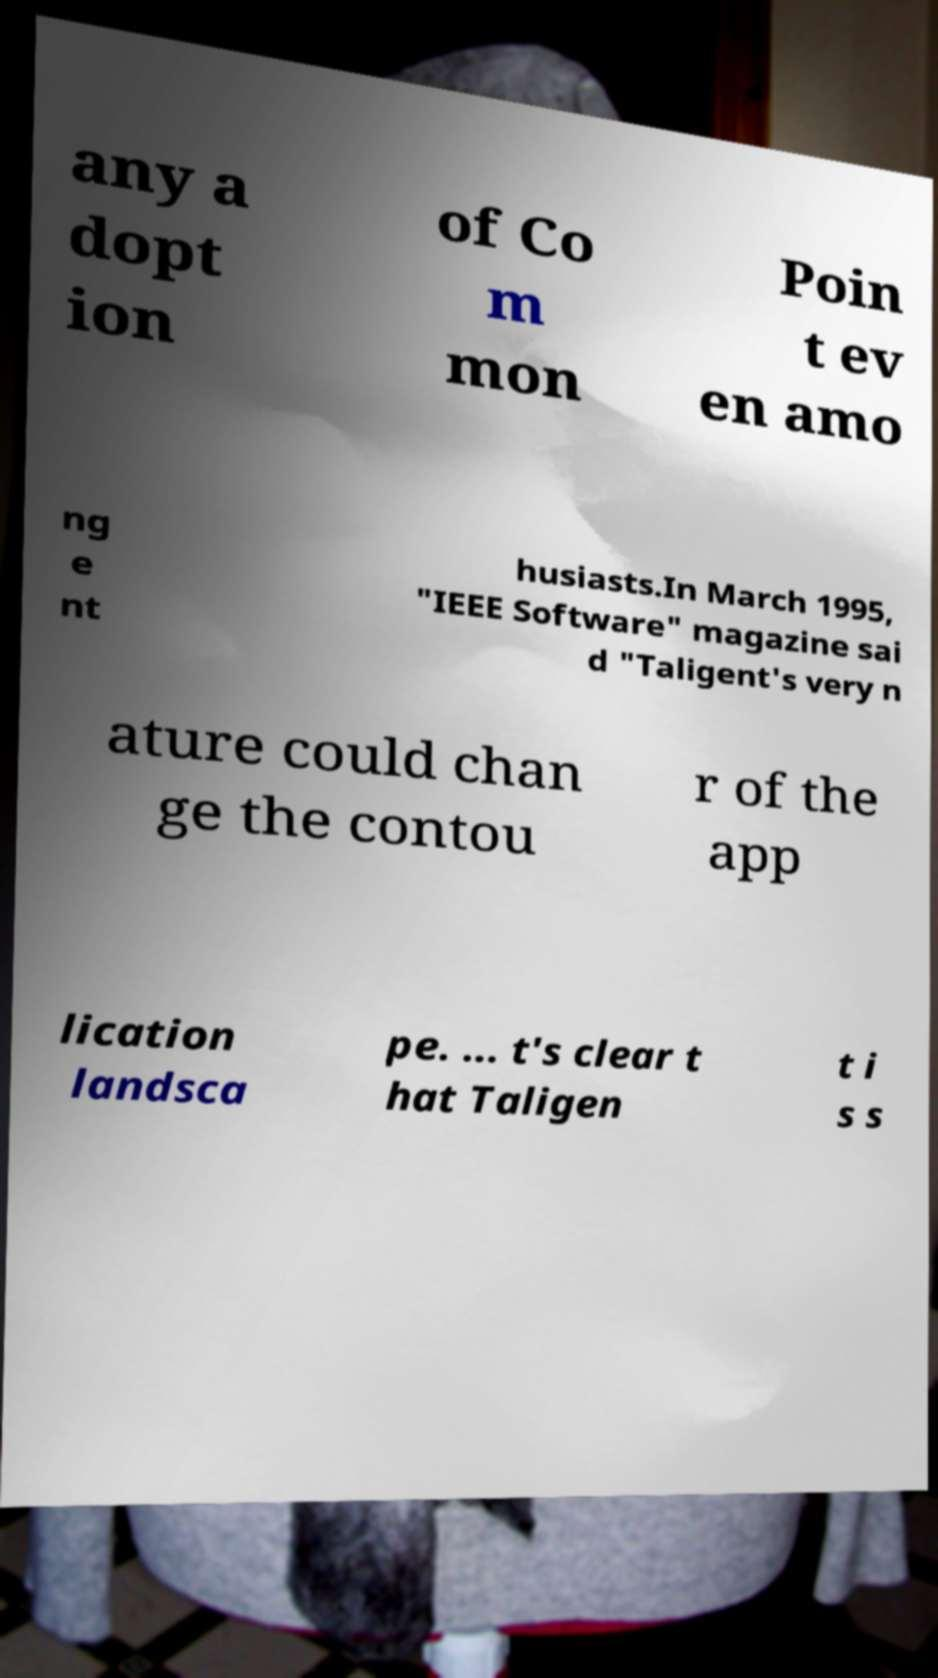For documentation purposes, I need the text within this image transcribed. Could you provide that? any a dopt ion of Co m mon Poin t ev en amo ng e nt husiasts.In March 1995, "IEEE Software" magazine sai d "Taligent's very n ature could chan ge the contou r of the app lication landsca pe. ... t's clear t hat Taligen t i s s 